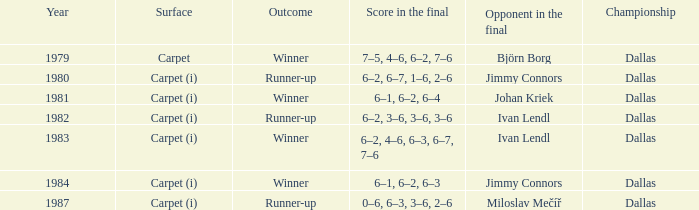Can you give me this table as a dict? {'header': ['Year', 'Surface', 'Outcome', 'Score in the final', 'Opponent in the final', 'Championship'], 'rows': [['1979', 'Carpet', 'Winner', '7–5, 4–6, 6–2, 7–6', 'Björn Borg', 'Dallas'], ['1980', 'Carpet (i)', 'Runner-up', '6–2, 6–7, 1–6, 2–6', 'Jimmy Connors', 'Dallas'], ['1981', 'Carpet (i)', 'Winner', '6–1, 6–2, 6–4', 'Johan Kriek', 'Dallas'], ['1982', 'Carpet (i)', 'Runner-up', '6–2, 3–6, 3–6, 3–6', 'Ivan Lendl', 'Dallas'], ['1983', 'Carpet (i)', 'Winner', '6–2, 4–6, 6–3, 6–7, 7–6', 'Ivan Lendl', 'Dallas'], ['1984', 'Carpet (i)', 'Winner', '6–1, 6–2, 6–3', 'Jimmy Connors', 'Dallas'], ['1987', 'Carpet (i)', 'Runner-up', '0–6, 6–3, 3–6, 2–6', 'Miloslav Mečíř', 'Dallas']]} How many outcomes are listed when the final opponent was Johan Kriek?  1.0. 